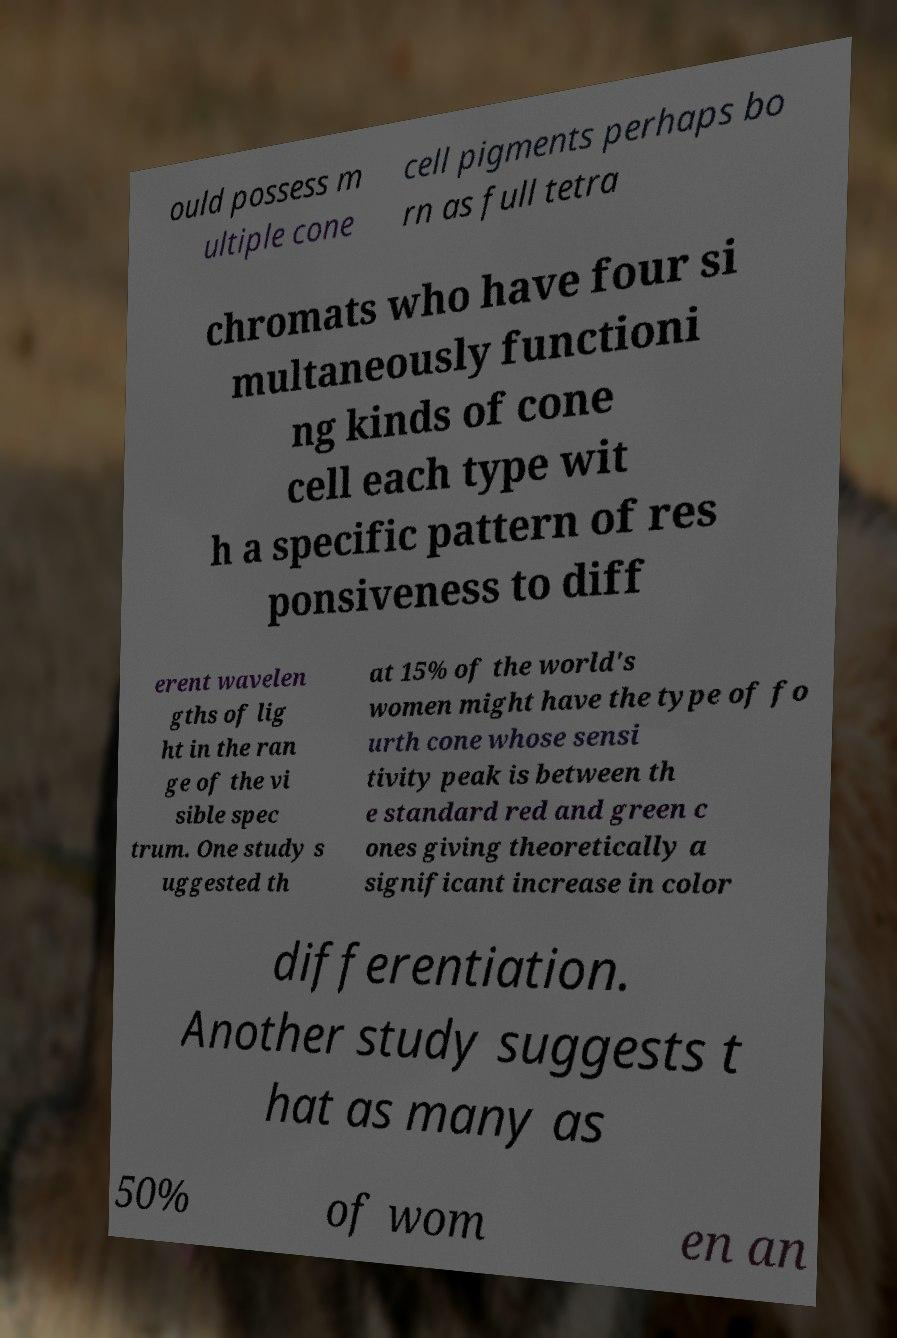I need the written content from this picture converted into text. Can you do that? ould possess m ultiple cone cell pigments perhaps bo rn as full tetra chromats who have four si multaneously functioni ng kinds of cone cell each type wit h a specific pattern of res ponsiveness to diff erent wavelen gths of lig ht in the ran ge of the vi sible spec trum. One study s uggested th at 15% of the world's women might have the type of fo urth cone whose sensi tivity peak is between th e standard red and green c ones giving theoretically a significant increase in color differentiation. Another study suggests t hat as many as 50% of wom en an 